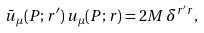<formula> <loc_0><loc_0><loc_500><loc_500>\bar { u } _ { \mu } ( P ; r ^ { \prime } ) \, u _ { \mu } ( P ; r ) = 2 M \, \delta ^ { r ^ { \prime } r } ,</formula> 